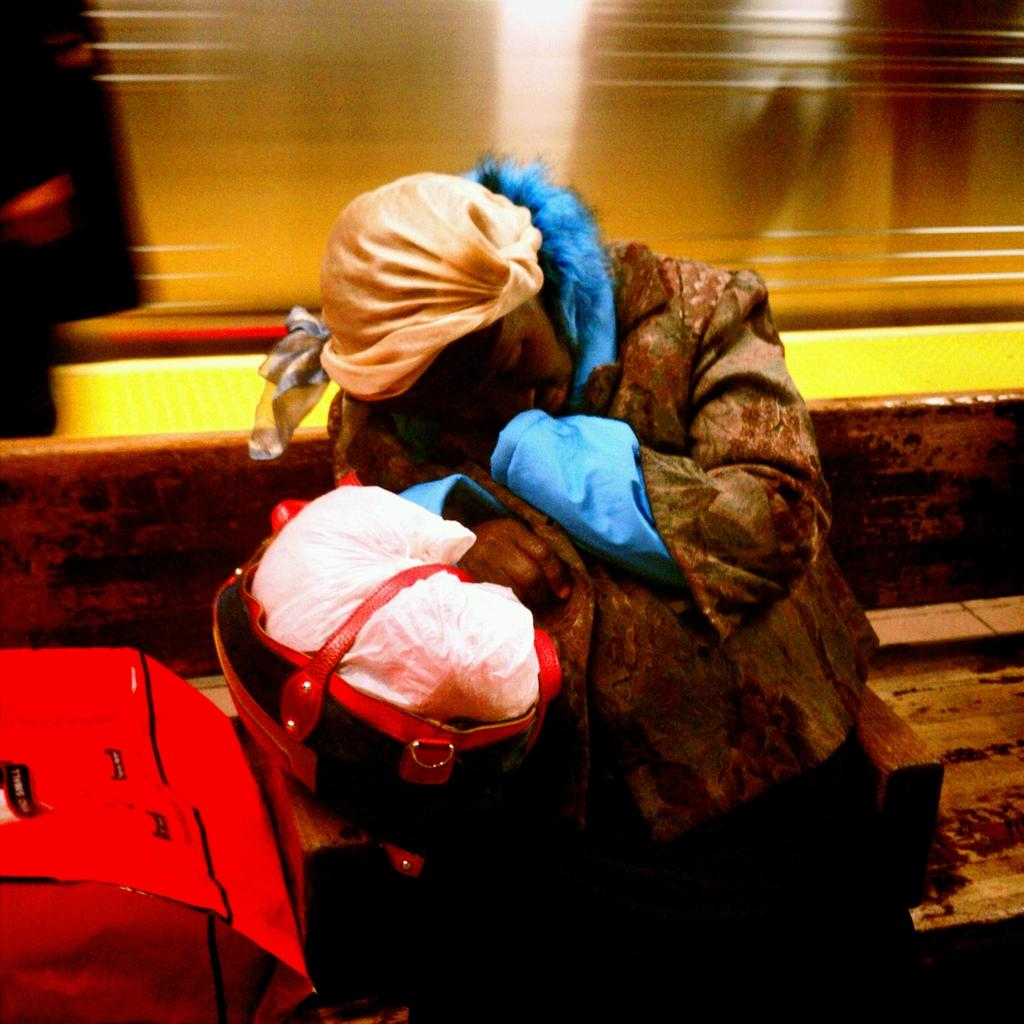What is the person in the image doing? There is a person sitting on a bench in the image. What else can be seen in the image besides the person? There are bags in the image. What type of object can be seen in the background of the image? There is a steel object in the background of the image. How does the person in the image order a drink? There is no indication in the image that the person is ordering a drink, so it cannot be determined from the picture. 